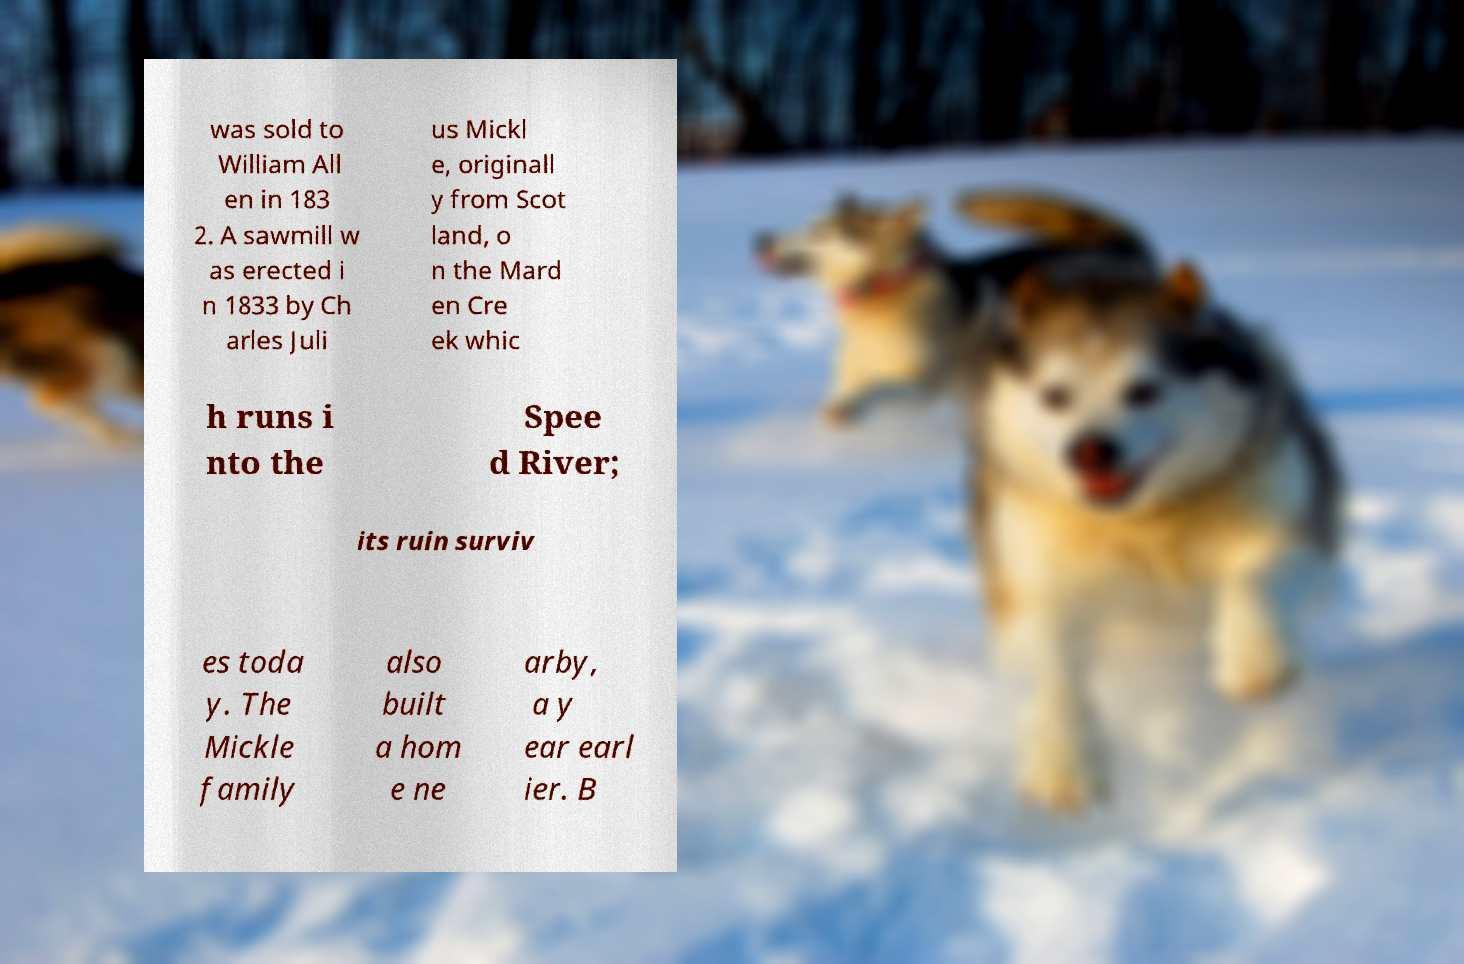There's text embedded in this image that I need extracted. Can you transcribe it verbatim? was sold to William All en in 183 2. A sawmill w as erected i n 1833 by Ch arles Juli us Mickl e, originall y from Scot land, o n the Mard en Cre ek whic h runs i nto the Spee d River; its ruin surviv es toda y. The Mickle family also built a hom e ne arby, a y ear earl ier. B 